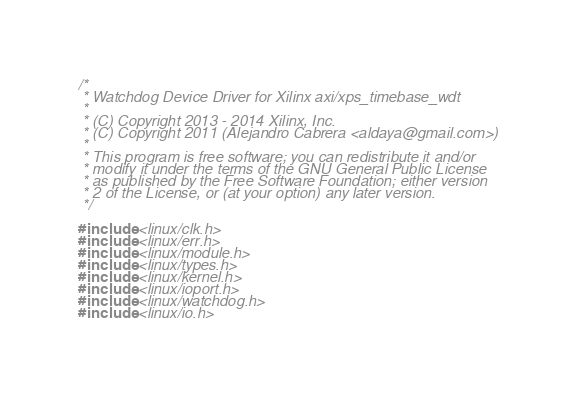<code> <loc_0><loc_0><loc_500><loc_500><_C_>/*
 * Watchdog Device Driver for Xilinx axi/xps_timebase_wdt
 *
 * (C) Copyright 2013 - 2014 Xilinx, Inc.
 * (C) Copyright 2011 (Alejandro Cabrera <aldaya@gmail.com>)
 *
 * This program is free software; you can redistribute it and/or
 * modify it under the terms of the GNU General Public License
 * as published by the Free Software Foundation; either version
 * 2 of the License, or (at your option) any later version.
 */

#include <linux/clk.h>
#include <linux/err.h>
#include <linux/module.h>
#include <linux/types.h>
#include <linux/kernel.h>
#include <linux/ioport.h>
#include <linux/watchdog.h>
#include <linux/io.h></code> 